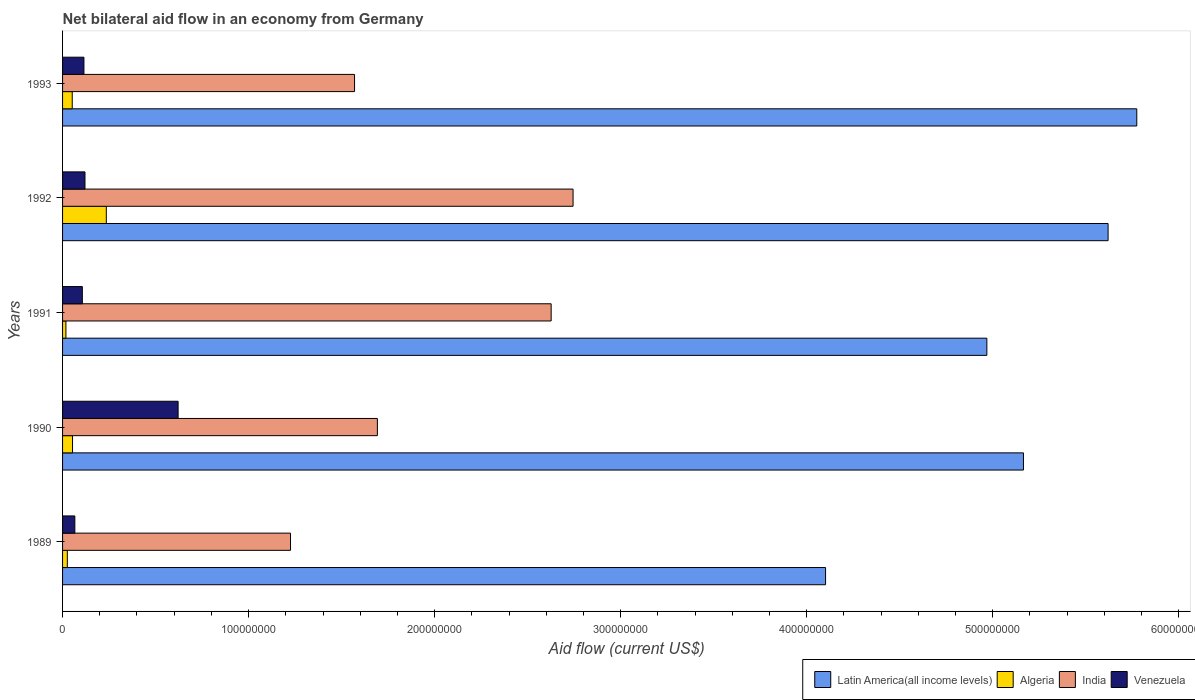Are the number of bars on each tick of the Y-axis equal?
Provide a short and direct response. Yes. How many bars are there on the 4th tick from the top?
Your answer should be compact. 4. What is the label of the 2nd group of bars from the top?
Give a very brief answer. 1992. What is the net bilateral aid flow in Algeria in 1993?
Provide a short and direct response. 5.20e+06. Across all years, what is the maximum net bilateral aid flow in Latin America(all income levels)?
Your answer should be very brief. 5.77e+08. Across all years, what is the minimum net bilateral aid flow in Algeria?
Provide a short and direct response. 1.80e+06. In which year was the net bilateral aid flow in Latin America(all income levels) minimum?
Ensure brevity in your answer.  1989. What is the total net bilateral aid flow in Latin America(all income levels) in the graph?
Provide a succinct answer. 2.56e+09. What is the difference between the net bilateral aid flow in Algeria in 1990 and that in 1992?
Offer a terse response. -1.82e+07. What is the difference between the net bilateral aid flow in Algeria in 1990 and the net bilateral aid flow in India in 1993?
Make the answer very short. -1.52e+08. What is the average net bilateral aid flow in Algeria per year?
Your response must be concise. 7.69e+06. In the year 1991, what is the difference between the net bilateral aid flow in India and net bilateral aid flow in Latin America(all income levels)?
Your answer should be very brief. -2.34e+08. What is the ratio of the net bilateral aid flow in Venezuela in 1992 to that in 1993?
Keep it short and to the point. 1.05. What is the difference between the highest and the second highest net bilateral aid flow in India?
Your answer should be compact. 1.18e+07. What is the difference between the highest and the lowest net bilateral aid flow in Latin America(all income levels)?
Keep it short and to the point. 1.67e+08. In how many years, is the net bilateral aid flow in Latin America(all income levels) greater than the average net bilateral aid flow in Latin America(all income levels) taken over all years?
Ensure brevity in your answer.  3. What does the 1st bar from the top in 1991 represents?
Ensure brevity in your answer.  Venezuela. How many years are there in the graph?
Keep it short and to the point. 5. What is the difference between two consecutive major ticks on the X-axis?
Your answer should be very brief. 1.00e+08. Does the graph contain any zero values?
Offer a very short reply. No. What is the title of the graph?
Ensure brevity in your answer.  Net bilateral aid flow in an economy from Germany. Does "Cayman Islands" appear as one of the legend labels in the graph?
Provide a short and direct response. No. What is the Aid flow (current US$) of Latin America(all income levels) in 1989?
Provide a short and direct response. 4.10e+08. What is the Aid flow (current US$) in Algeria in 1989?
Your answer should be very brief. 2.56e+06. What is the Aid flow (current US$) of India in 1989?
Provide a succinct answer. 1.23e+08. What is the Aid flow (current US$) in Venezuela in 1989?
Provide a succinct answer. 6.60e+06. What is the Aid flow (current US$) in Latin America(all income levels) in 1990?
Make the answer very short. 5.17e+08. What is the Aid flow (current US$) in Algeria in 1990?
Your response must be concise. 5.36e+06. What is the Aid flow (current US$) in India in 1990?
Your answer should be very brief. 1.69e+08. What is the Aid flow (current US$) of Venezuela in 1990?
Offer a terse response. 6.21e+07. What is the Aid flow (current US$) in Latin America(all income levels) in 1991?
Ensure brevity in your answer.  4.97e+08. What is the Aid flow (current US$) of Algeria in 1991?
Make the answer very short. 1.80e+06. What is the Aid flow (current US$) of India in 1991?
Give a very brief answer. 2.63e+08. What is the Aid flow (current US$) of Venezuela in 1991?
Offer a very short reply. 1.06e+07. What is the Aid flow (current US$) in Latin America(all income levels) in 1992?
Provide a succinct answer. 5.62e+08. What is the Aid flow (current US$) of Algeria in 1992?
Your response must be concise. 2.35e+07. What is the Aid flow (current US$) in India in 1992?
Make the answer very short. 2.74e+08. What is the Aid flow (current US$) in Venezuela in 1992?
Keep it short and to the point. 1.20e+07. What is the Aid flow (current US$) in Latin America(all income levels) in 1993?
Ensure brevity in your answer.  5.77e+08. What is the Aid flow (current US$) in Algeria in 1993?
Keep it short and to the point. 5.20e+06. What is the Aid flow (current US$) of India in 1993?
Offer a very short reply. 1.57e+08. What is the Aid flow (current US$) in Venezuela in 1993?
Keep it short and to the point. 1.15e+07. Across all years, what is the maximum Aid flow (current US$) in Latin America(all income levels)?
Provide a short and direct response. 5.77e+08. Across all years, what is the maximum Aid flow (current US$) of Algeria?
Provide a succinct answer. 2.35e+07. Across all years, what is the maximum Aid flow (current US$) of India?
Keep it short and to the point. 2.74e+08. Across all years, what is the maximum Aid flow (current US$) of Venezuela?
Offer a very short reply. 6.21e+07. Across all years, what is the minimum Aid flow (current US$) of Latin America(all income levels)?
Provide a short and direct response. 4.10e+08. Across all years, what is the minimum Aid flow (current US$) of Algeria?
Give a very brief answer. 1.80e+06. Across all years, what is the minimum Aid flow (current US$) in India?
Your answer should be compact. 1.23e+08. Across all years, what is the minimum Aid flow (current US$) of Venezuela?
Your answer should be very brief. 6.60e+06. What is the total Aid flow (current US$) in Latin America(all income levels) in the graph?
Your response must be concise. 2.56e+09. What is the total Aid flow (current US$) in Algeria in the graph?
Ensure brevity in your answer.  3.84e+07. What is the total Aid flow (current US$) of India in the graph?
Your response must be concise. 9.86e+08. What is the total Aid flow (current US$) of Venezuela in the graph?
Your response must be concise. 1.03e+08. What is the difference between the Aid flow (current US$) of Latin America(all income levels) in 1989 and that in 1990?
Offer a terse response. -1.06e+08. What is the difference between the Aid flow (current US$) in Algeria in 1989 and that in 1990?
Offer a very short reply. -2.80e+06. What is the difference between the Aid flow (current US$) of India in 1989 and that in 1990?
Your answer should be compact. -4.67e+07. What is the difference between the Aid flow (current US$) of Venezuela in 1989 and that in 1990?
Provide a succinct answer. -5.55e+07. What is the difference between the Aid flow (current US$) in Latin America(all income levels) in 1989 and that in 1991?
Give a very brief answer. -8.67e+07. What is the difference between the Aid flow (current US$) in Algeria in 1989 and that in 1991?
Keep it short and to the point. 7.60e+05. What is the difference between the Aid flow (current US$) in India in 1989 and that in 1991?
Your answer should be compact. -1.40e+08. What is the difference between the Aid flow (current US$) in Venezuela in 1989 and that in 1991?
Make the answer very short. -4.03e+06. What is the difference between the Aid flow (current US$) in Latin America(all income levels) in 1989 and that in 1992?
Provide a short and direct response. -1.52e+08. What is the difference between the Aid flow (current US$) in Algeria in 1989 and that in 1992?
Provide a succinct answer. -2.10e+07. What is the difference between the Aid flow (current US$) of India in 1989 and that in 1992?
Make the answer very short. -1.52e+08. What is the difference between the Aid flow (current US$) of Venezuela in 1989 and that in 1992?
Your answer should be compact. -5.45e+06. What is the difference between the Aid flow (current US$) of Latin America(all income levels) in 1989 and that in 1993?
Provide a succinct answer. -1.67e+08. What is the difference between the Aid flow (current US$) in Algeria in 1989 and that in 1993?
Your response must be concise. -2.64e+06. What is the difference between the Aid flow (current US$) in India in 1989 and that in 1993?
Make the answer very short. -3.44e+07. What is the difference between the Aid flow (current US$) of Venezuela in 1989 and that in 1993?
Your answer should be very brief. -4.89e+06. What is the difference between the Aid flow (current US$) in Latin America(all income levels) in 1990 and that in 1991?
Offer a terse response. 1.97e+07. What is the difference between the Aid flow (current US$) in Algeria in 1990 and that in 1991?
Ensure brevity in your answer.  3.56e+06. What is the difference between the Aid flow (current US$) of India in 1990 and that in 1991?
Your answer should be compact. -9.34e+07. What is the difference between the Aid flow (current US$) of Venezuela in 1990 and that in 1991?
Your answer should be very brief. 5.15e+07. What is the difference between the Aid flow (current US$) in Latin America(all income levels) in 1990 and that in 1992?
Provide a succinct answer. -4.55e+07. What is the difference between the Aid flow (current US$) of Algeria in 1990 and that in 1992?
Offer a terse response. -1.82e+07. What is the difference between the Aid flow (current US$) in India in 1990 and that in 1992?
Provide a short and direct response. -1.05e+08. What is the difference between the Aid flow (current US$) of Venezuela in 1990 and that in 1992?
Your answer should be compact. 5.01e+07. What is the difference between the Aid flow (current US$) of Latin America(all income levels) in 1990 and that in 1993?
Provide a short and direct response. -6.09e+07. What is the difference between the Aid flow (current US$) of Algeria in 1990 and that in 1993?
Make the answer very short. 1.60e+05. What is the difference between the Aid flow (current US$) of India in 1990 and that in 1993?
Offer a very short reply. 1.23e+07. What is the difference between the Aid flow (current US$) in Venezuela in 1990 and that in 1993?
Ensure brevity in your answer.  5.06e+07. What is the difference between the Aid flow (current US$) in Latin America(all income levels) in 1991 and that in 1992?
Your response must be concise. -6.52e+07. What is the difference between the Aid flow (current US$) in Algeria in 1991 and that in 1992?
Give a very brief answer. -2.17e+07. What is the difference between the Aid flow (current US$) in India in 1991 and that in 1992?
Make the answer very short. -1.18e+07. What is the difference between the Aid flow (current US$) in Venezuela in 1991 and that in 1992?
Ensure brevity in your answer.  -1.42e+06. What is the difference between the Aid flow (current US$) in Latin America(all income levels) in 1991 and that in 1993?
Keep it short and to the point. -8.06e+07. What is the difference between the Aid flow (current US$) of Algeria in 1991 and that in 1993?
Ensure brevity in your answer.  -3.40e+06. What is the difference between the Aid flow (current US$) of India in 1991 and that in 1993?
Ensure brevity in your answer.  1.06e+08. What is the difference between the Aid flow (current US$) of Venezuela in 1991 and that in 1993?
Offer a terse response. -8.60e+05. What is the difference between the Aid flow (current US$) in Latin America(all income levels) in 1992 and that in 1993?
Keep it short and to the point. -1.54e+07. What is the difference between the Aid flow (current US$) in Algeria in 1992 and that in 1993?
Offer a terse response. 1.83e+07. What is the difference between the Aid flow (current US$) in India in 1992 and that in 1993?
Ensure brevity in your answer.  1.17e+08. What is the difference between the Aid flow (current US$) in Venezuela in 1992 and that in 1993?
Provide a short and direct response. 5.60e+05. What is the difference between the Aid flow (current US$) in Latin America(all income levels) in 1989 and the Aid flow (current US$) in Algeria in 1990?
Your answer should be compact. 4.05e+08. What is the difference between the Aid flow (current US$) of Latin America(all income levels) in 1989 and the Aid flow (current US$) of India in 1990?
Your response must be concise. 2.41e+08. What is the difference between the Aid flow (current US$) in Latin America(all income levels) in 1989 and the Aid flow (current US$) in Venezuela in 1990?
Your response must be concise. 3.48e+08. What is the difference between the Aid flow (current US$) of Algeria in 1989 and the Aid flow (current US$) of India in 1990?
Provide a short and direct response. -1.67e+08. What is the difference between the Aid flow (current US$) in Algeria in 1989 and the Aid flow (current US$) in Venezuela in 1990?
Provide a short and direct response. -5.96e+07. What is the difference between the Aid flow (current US$) of India in 1989 and the Aid flow (current US$) of Venezuela in 1990?
Provide a succinct answer. 6.04e+07. What is the difference between the Aid flow (current US$) of Latin America(all income levels) in 1989 and the Aid flow (current US$) of Algeria in 1991?
Keep it short and to the point. 4.08e+08. What is the difference between the Aid flow (current US$) in Latin America(all income levels) in 1989 and the Aid flow (current US$) in India in 1991?
Ensure brevity in your answer.  1.48e+08. What is the difference between the Aid flow (current US$) in Latin America(all income levels) in 1989 and the Aid flow (current US$) in Venezuela in 1991?
Provide a short and direct response. 4.00e+08. What is the difference between the Aid flow (current US$) of Algeria in 1989 and the Aid flow (current US$) of India in 1991?
Make the answer very short. -2.60e+08. What is the difference between the Aid flow (current US$) in Algeria in 1989 and the Aid flow (current US$) in Venezuela in 1991?
Your answer should be compact. -8.07e+06. What is the difference between the Aid flow (current US$) of India in 1989 and the Aid flow (current US$) of Venezuela in 1991?
Keep it short and to the point. 1.12e+08. What is the difference between the Aid flow (current US$) in Latin America(all income levels) in 1989 and the Aid flow (current US$) in Algeria in 1992?
Your answer should be compact. 3.87e+08. What is the difference between the Aid flow (current US$) of Latin America(all income levels) in 1989 and the Aid flow (current US$) of India in 1992?
Provide a short and direct response. 1.36e+08. What is the difference between the Aid flow (current US$) in Latin America(all income levels) in 1989 and the Aid flow (current US$) in Venezuela in 1992?
Your response must be concise. 3.98e+08. What is the difference between the Aid flow (current US$) in Algeria in 1989 and the Aid flow (current US$) in India in 1992?
Provide a succinct answer. -2.72e+08. What is the difference between the Aid flow (current US$) in Algeria in 1989 and the Aid flow (current US$) in Venezuela in 1992?
Offer a terse response. -9.49e+06. What is the difference between the Aid flow (current US$) in India in 1989 and the Aid flow (current US$) in Venezuela in 1992?
Keep it short and to the point. 1.10e+08. What is the difference between the Aid flow (current US$) in Latin America(all income levels) in 1989 and the Aid flow (current US$) in Algeria in 1993?
Offer a terse response. 4.05e+08. What is the difference between the Aid flow (current US$) in Latin America(all income levels) in 1989 and the Aid flow (current US$) in India in 1993?
Your answer should be compact. 2.53e+08. What is the difference between the Aid flow (current US$) of Latin America(all income levels) in 1989 and the Aid flow (current US$) of Venezuela in 1993?
Give a very brief answer. 3.99e+08. What is the difference between the Aid flow (current US$) of Algeria in 1989 and the Aid flow (current US$) of India in 1993?
Make the answer very short. -1.54e+08. What is the difference between the Aid flow (current US$) of Algeria in 1989 and the Aid flow (current US$) of Venezuela in 1993?
Your answer should be compact. -8.93e+06. What is the difference between the Aid flow (current US$) of India in 1989 and the Aid flow (current US$) of Venezuela in 1993?
Give a very brief answer. 1.11e+08. What is the difference between the Aid flow (current US$) of Latin America(all income levels) in 1990 and the Aid flow (current US$) of Algeria in 1991?
Ensure brevity in your answer.  5.15e+08. What is the difference between the Aid flow (current US$) in Latin America(all income levels) in 1990 and the Aid flow (current US$) in India in 1991?
Your response must be concise. 2.54e+08. What is the difference between the Aid flow (current US$) in Latin America(all income levels) in 1990 and the Aid flow (current US$) in Venezuela in 1991?
Provide a short and direct response. 5.06e+08. What is the difference between the Aid flow (current US$) in Algeria in 1990 and the Aid flow (current US$) in India in 1991?
Provide a succinct answer. -2.57e+08. What is the difference between the Aid flow (current US$) of Algeria in 1990 and the Aid flow (current US$) of Venezuela in 1991?
Provide a short and direct response. -5.27e+06. What is the difference between the Aid flow (current US$) of India in 1990 and the Aid flow (current US$) of Venezuela in 1991?
Make the answer very short. 1.59e+08. What is the difference between the Aid flow (current US$) of Latin America(all income levels) in 1990 and the Aid flow (current US$) of Algeria in 1992?
Your answer should be compact. 4.93e+08. What is the difference between the Aid flow (current US$) of Latin America(all income levels) in 1990 and the Aid flow (current US$) of India in 1992?
Keep it short and to the point. 2.42e+08. What is the difference between the Aid flow (current US$) of Latin America(all income levels) in 1990 and the Aid flow (current US$) of Venezuela in 1992?
Provide a succinct answer. 5.05e+08. What is the difference between the Aid flow (current US$) in Algeria in 1990 and the Aid flow (current US$) in India in 1992?
Your answer should be very brief. -2.69e+08. What is the difference between the Aid flow (current US$) in Algeria in 1990 and the Aid flow (current US$) in Venezuela in 1992?
Your answer should be compact. -6.69e+06. What is the difference between the Aid flow (current US$) in India in 1990 and the Aid flow (current US$) in Venezuela in 1992?
Offer a terse response. 1.57e+08. What is the difference between the Aid flow (current US$) in Latin America(all income levels) in 1990 and the Aid flow (current US$) in Algeria in 1993?
Make the answer very short. 5.11e+08. What is the difference between the Aid flow (current US$) of Latin America(all income levels) in 1990 and the Aid flow (current US$) of India in 1993?
Provide a succinct answer. 3.60e+08. What is the difference between the Aid flow (current US$) of Latin America(all income levels) in 1990 and the Aid flow (current US$) of Venezuela in 1993?
Provide a short and direct response. 5.05e+08. What is the difference between the Aid flow (current US$) of Algeria in 1990 and the Aid flow (current US$) of India in 1993?
Offer a terse response. -1.52e+08. What is the difference between the Aid flow (current US$) in Algeria in 1990 and the Aid flow (current US$) in Venezuela in 1993?
Make the answer very short. -6.13e+06. What is the difference between the Aid flow (current US$) in India in 1990 and the Aid flow (current US$) in Venezuela in 1993?
Your answer should be very brief. 1.58e+08. What is the difference between the Aid flow (current US$) in Latin America(all income levels) in 1991 and the Aid flow (current US$) in Algeria in 1992?
Give a very brief answer. 4.73e+08. What is the difference between the Aid flow (current US$) of Latin America(all income levels) in 1991 and the Aid flow (current US$) of India in 1992?
Keep it short and to the point. 2.22e+08. What is the difference between the Aid flow (current US$) of Latin America(all income levels) in 1991 and the Aid flow (current US$) of Venezuela in 1992?
Offer a very short reply. 4.85e+08. What is the difference between the Aid flow (current US$) of Algeria in 1991 and the Aid flow (current US$) of India in 1992?
Ensure brevity in your answer.  -2.73e+08. What is the difference between the Aid flow (current US$) in Algeria in 1991 and the Aid flow (current US$) in Venezuela in 1992?
Your response must be concise. -1.02e+07. What is the difference between the Aid flow (current US$) in India in 1991 and the Aid flow (current US$) in Venezuela in 1992?
Provide a short and direct response. 2.51e+08. What is the difference between the Aid flow (current US$) in Latin America(all income levels) in 1991 and the Aid flow (current US$) in Algeria in 1993?
Ensure brevity in your answer.  4.92e+08. What is the difference between the Aid flow (current US$) in Latin America(all income levels) in 1991 and the Aid flow (current US$) in India in 1993?
Your answer should be compact. 3.40e+08. What is the difference between the Aid flow (current US$) of Latin America(all income levels) in 1991 and the Aid flow (current US$) of Venezuela in 1993?
Your answer should be very brief. 4.85e+08. What is the difference between the Aid flow (current US$) of Algeria in 1991 and the Aid flow (current US$) of India in 1993?
Give a very brief answer. -1.55e+08. What is the difference between the Aid flow (current US$) of Algeria in 1991 and the Aid flow (current US$) of Venezuela in 1993?
Offer a very short reply. -9.69e+06. What is the difference between the Aid flow (current US$) in India in 1991 and the Aid flow (current US$) in Venezuela in 1993?
Provide a short and direct response. 2.51e+08. What is the difference between the Aid flow (current US$) in Latin America(all income levels) in 1992 and the Aid flow (current US$) in Algeria in 1993?
Make the answer very short. 5.57e+08. What is the difference between the Aid flow (current US$) in Latin America(all income levels) in 1992 and the Aid flow (current US$) in India in 1993?
Give a very brief answer. 4.05e+08. What is the difference between the Aid flow (current US$) in Latin America(all income levels) in 1992 and the Aid flow (current US$) in Venezuela in 1993?
Provide a succinct answer. 5.51e+08. What is the difference between the Aid flow (current US$) in Algeria in 1992 and the Aid flow (current US$) in India in 1993?
Offer a very short reply. -1.33e+08. What is the difference between the Aid flow (current US$) of Algeria in 1992 and the Aid flow (current US$) of Venezuela in 1993?
Your answer should be compact. 1.20e+07. What is the difference between the Aid flow (current US$) of India in 1992 and the Aid flow (current US$) of Venezuela in 1993?
Offer a very short reply. 2.63e+08. What is the average Aid flow (current US$) in Latin America(all income levels) per year?
Give a very brief answer. 5.13e+08. What is the average Aid flow (current US$) of Algeria per year?
Your answer should be compact. 7.69e+06. What is the average Aid flow (current US$) of India per year?
Give a very brief answer. 1.97e+08. What is the average Aid flow (current US$) in Venezuela per year?
Give a very brief answer. 2.06e+07. In the year 1989, what is the difference between the Aid flow (current US$) of Latin America(all income levels) and Aid flow (current US$) of Algeria?
Give a very brief answer. 4.08e+08. In the year 1989, what is the difference between the Aid flow (current US$) of Latin America(all income levels) and Aid flow (current US$) of India?
Keep it short and to the point. 2.88e+08. In the year 1989, what is the difference between the Aid flow (current US$) in Latin America(all income levels) and Aid flow (current US$) in Venezuela?
Offer a very short reply. 4.04e+08. In the year 1989, what is the difference between the Aid flow (current US$) of Algeria and Aid flow (current US$) of India?
Provide a succinct answer. -1.20e+08. In the year 1989, what is the difference between the Aid flow (current US$) in Algeria and Aid flow (current US$) in Venezuela?
Keep it short and to the point. -4.04e+06. In the year 1989, what is the difference between the Aid flow (current US$) of India and Aid flow (current US$) of Venezuela?
Ensure brevity in your answer.  1.16e+08. In the year 1990, what is the difference between the Aid flow (current US$) in Latin America(all income levels) and Aid flow (current US$) in Algeria?
Your answer should be very brief. 5.11e+08. In the year 1990, what is the difference between the Aid flow (current US$) in Latin America(all income levels) and Aid flow (current US$) in India?
Your answer should be compact. 3.47e+08. In the year 1990, what is the difference between the Aid flow (current US$) in Latin America(all income levels) and Aid flow (current US$) in Venezuela?
Provide a succinct answer. 4.54e+08. In the year 1990, what is the difference between the Aid flow (current US$) in Algeria and Aid flow (current US$) in India?
Make the answer very short. -1.64e+08. In the year 1990, what is the difference between the Aid flow (current US$) in Algeria and Aid flow (current US$) in Venezuela?
Offer a terse response. -5.68e+07. In the year 1990, what is the difference between the Aid flow (current US$) of India and Aid flow (current US$) of Venezuela?
Your answer should be compact. 1.07e+08. In the year 1991, what is the difference between the Aid flow (current US$) in Latin America(all income levels) and Aid flow (current US$) in Algeria?
Give a very brief answer. 4.95e+08. In the year 1991, what is the difference between the Aid flow (current US$) in Latin America(all income levels) and Aid flow (current US$) in India?
Your answer should be compact. 2.34e+08. In the year 1991, what is the difference between the Aid flow (current US$) of Latin America(all income levels) and Aid flow (current US$) of Venezuela?
Make the answer very short. 4.86e+08. In the year 1991, what is the difference between the Aid flow (current US$) of Algeria and Aid flow (current US$) of India?
Your answer should be compact. -2.61e+08. In the year 1991, what is the difference between the Aid flow (current US$) of Algeria and Aid flow (current US$) of Venezuela?
Provide a succinct answer. -8.83e+06. In the year 1991, what is the difference between the Aid flow (current US$) of India and Aid flow (current US$) of Venezuela?
Ensure brevity in your answer.  2.52e+08. In the year 1992, what is the difference between the Aid flow (current US$) of Latin America(all income levels) and Aid flow (current US$) of Algeria?
Keep it short and to the point. 5.39e+08. In the year 1992, what is the difference between the Aid flow (current US$) in Latin America(all income levels) and Aid flow (current US$) in India?
Offer a terse response. 2.88e+08. In the year 1992, what is the difference between the Aid flow (current US$) in Latin America(all income levels) and Aid flow (current US$) in Venezuela?
Offer a very short reply. 5.50e+08. In the year 1992, what is the difference between the Aid flow (current US$) in Algeria and Aid flow (current US$) in India?
Provide a succinct answer. -2.51e+08. In the year 1992, what is the difference between the Aid flow (current US$) in Algeria and Aid flow (current US$) in Venezuela?
Make the answer very short. 1.15e+07. In the year 1992, what is the difference between the Aid flow (current US$) of India and Aid flow (current US$) of Venezuela?
Provide a short and direct response. 2.62e+08. In the year 1993, what is the difference between the Aid flow (current US$) of Latin America(all income levels) and Aid flow (current US$) of Algeria?
Your answer should be very brief. 5.72e+08. In the year 1993, what is the difference between the Aid flow (current US$) in Latin America(all income levels) and Aid flow (current US$) in India?
Make the answer very short. 4.21e+08. In the year 1993, what is the difference between the Aid flow (current US$) in Latin America(all income levels) and Aid flow (current US$) in Venezuela?
Offer a very short reply. 5.66e+08. In the year 1993, what is the difference between the Aid flow (current US$) in Algeria and Aid flow (current US$) in India?
Offer a very short reply. -1.52e+08. In the year 1993, what is the difference between the Aid flow (current US$) of Algeria and Aid flow (current US$) of Venezuela?
Ensure brevity in your answer.  -6.29e+06. In the year 1993, what is the difference between the Aid flow (current US$) in India and Aid flow (current US$) in Venezuela?
Your answer should be very brief. 1.45e+08. What is the ratio of the Aid flow (current US$) in Latin America(all income levels) in 1989 to that in 1990?
Your answer should be very brief. 0.79. What is the ratio of the Aid flow (current US$) of Algeria in 1989 to that in 1990?
Ensure brevity in your answer.  0.48. What is the ratio of the Aid flow (current US$) in India in 1989 to that in 1990?
Provide a short and direct response. 0.72. What is the ratio of the Aid flow (current US$) in Venezuela in 1989 to that in 1990?
Offer a very short reply. 0.11. What is the ratio of the Aid flow (current US$) of Latin America(all income levels) in 1989 to that in 1991?
Your answer should be compact. 0.83. What is the ratio of the Aid flow (current US$) of Algeria in 1989 to that in 1991?
Offer a terse response. 1.42. What is the ratio of the Aid flow (current US$) in India in 1989 to that in 1991?
Provide a short and direct response. 0.47. What is the ratio of the Aid flow (current US$) in Venezuela in 1989 to that in 1991?
Make the answer very short. 0.62. What is the ratio of the Aid flow (current US$) of Latin America(all income levels) in 1989 to that in 1992?
Provide a succinct answer. 0.73. What is the ratio of the Aid flow (current US$) in Algeria in 1989 to that in 1992?
Offer a terse response. 0.11. What is the ratio of the Aid flow (current US$) in India in 1989 to that in 1992?
Provide a succinct answer. 0.45. What is the ratio of the Aid flow (current US$) in Venezuela in 1989 to that in 1992?
Your answer should be very brief. 0.55. What is the ratio of the Aid flow (current US$) in Latin America(all income levels) in 1989 to that in 1993?
Your answer should be compact. 0.71. What is the ratio of the Aid flow (current US$) of Algeria in 1989 to that in 1993?
Ensure brevity in your answer.  0.49. What is the ratio of the Aid flow (current US$) of India in 1989 to that in 1993?
Your answer should be very brief. 0.78. What is the ratio of the Aid flow (current US$) in Venezuela in 1989 to that in 1993?
Provide a short and direct response. 0.57. What is the ratio of the Aid flow (current US$) of Latin America(all income levels) in 1990 to that in 1991?
Your answer should be very brief. 1.04. What is the ratio of the Aid flow (current US$) of Algeria in 1990 to that in 1991?
Your response must be concise. 2.98. What is the ratio of the Aid flow (current US$) of India in 1990 to that in 1991?
Your answer should be very brief. 0.64. What is the ratio of the Aid flow (current US$) in Venezuela in 1990 to that in 1991?
Ensure brevity in your answer.  5.84. What is the ratio of the Aid flow (current US$) of Latin America(all income levels) in 1990 to that in 1992?
Your answer should be compact. 0.92. What is the ratio of the Aid flow (current US$) in Algeria in 1990 to that in 1992?
Offer a very short reply. 0.23. What is the ratio of the Aid flow (current US$) of India in 1990 to that in 1992?
Your answer should be compact. 0.62. What is the ratio of the Aid flow (current US$) of Venezuela in 1990 to that in 1992?
Provide a succinct answer. 5.15. What is the ratio of the Aid flow (current US$) of Latin America(all income levels) in 1990 to that in 1993?
Provide a succinct answer. 0.89. What is the ratio of the Aid flow (current US$) in Algeria in 1990 to that in 1993?
Keep it short and to the point. 1.03. What is the ratio of the Aid flow (current US$) in India in 1990 to that in 1993?
Your answer should be compact. 1.08. What is the ratio of the Aid flow (current US$) in Venezuela in 1990 to that in 1993?
Your answer should be compact. 5.41. What is the ratio of the Aid flow (current US$) in Latin America(all income levels) in 1991 to that in 1992?
Offer a terse response. 0.88. What is the ratio of the Aid flow (current US$) of Algeria in 1991 to that in 1992?
Give a very brief answer. 0.08. What is the ratio of the Aid flow (current US$) of India in 1991 to that in 1992?
Keep it short and to the point. 0.96. What is the ratio of the Aid flow (current US$) of Venezuela in 1991 to that in 1992?
Provide a succinct answer. 0.88. What is the ratio of the Aid flow (current US$) in Latin America(all income levels) in 1991 to that in 1993?
Give a very brief answer. 0.86. What is the ratio of the Aid flow (current US$) in Algeria in 1991 to that in 1993?
Provide a short and direct response. 0.35. What is the ratio of the Aid flow (current US$) of India in 1991 to that in 1993?
Ensure brevity in your answer.  1.67. What is the ratio of the Aid flow (current US$) in Venezuela in 1991 to that in 1993?
Offer a very short reply. 0.93. What is the ratio of the Aid flow (current US$) of Latin America(all income levels) in 1992 to that in 1993?
Your answer should be compact. 0.97. What is the ratio of the Aid flow (current US$) of Algeria in 1992 to that in 1993?
Provide a short and direct response. 4.52. What is the ratio of the Aid flow (current US$) of India in 1992 to that in 1993?
Make the answer very short. 1.75. What is the ratio of the Aid flow (current US$) in Venezuela in 1992 to that in 1993?
Provide a succinct answer. 1.05. What is the difference between the highest and the second highest Aid flow (current US$) in Latin America(all income levels)?
Ensure brevity in your answer.  1.54e+07. What is the difference between the highest and the second highest Aid flow (current US$) of Algeria?
Your answer should be very brief. 1.82e+07. What is the difference between the highest and the second highest Aid flow (current US$) of India?
Keep it short and to the point. 1.18e+07. What is the difference between the highest and the second highest Aid flow (current US$) of Venezuela?
Give a very brief answer. 5.01e+07. What is the difference between the highest and the lowest Aid flow (current US$) of Latin America(all income levels)?
Provide a succinct answer. 1.67e+08. What is the difference between the highest and the lowest Aid flow (current US$) in Algeria?
Offer a terse response. 2.17e+07. What is the difference between the highest and the lowest Aid flow (current US$) in India?
Give a very brief answer. 1.52e+08. What is the difference between the highest and the lowest Aid flow (current US$) in Venezuela?
Your answer should be very brief. 5.55e+07. 